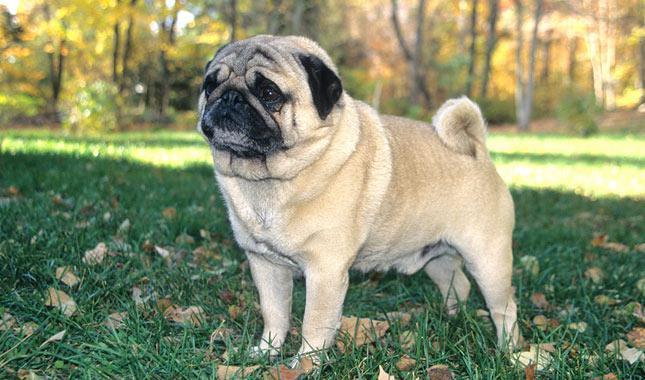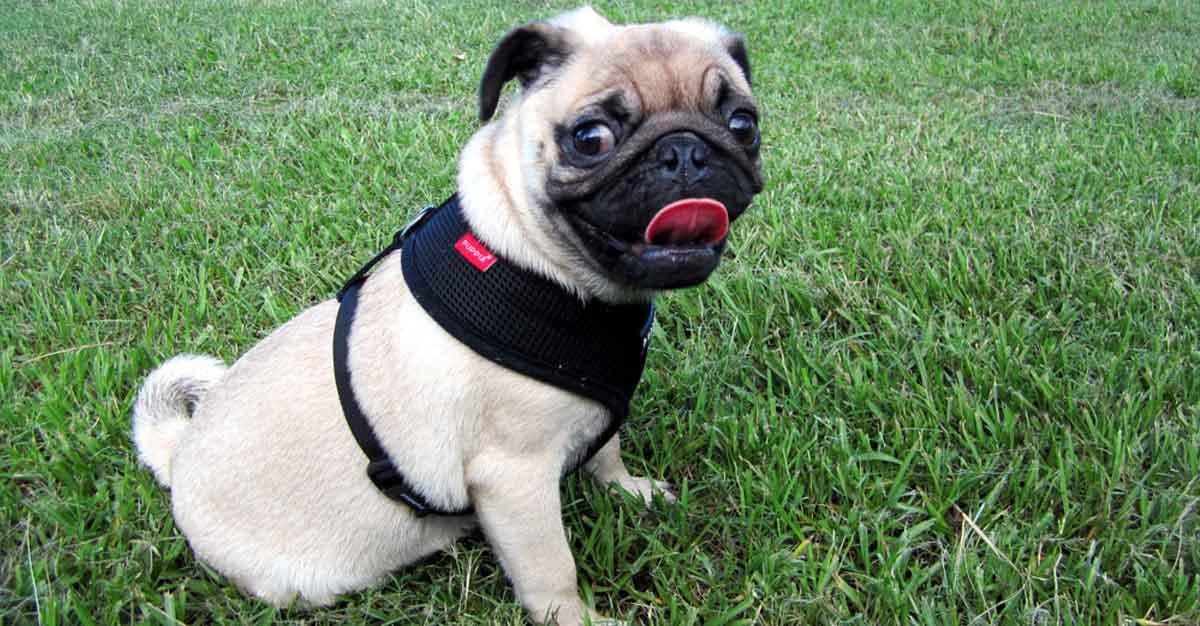The first image is the image on the left, the second image is the image on the right. For the images displayed, is the sentence "All dogs are shown on green grass, and no dog is in an action pose." factually correct? Answer yes or no. Yes. 